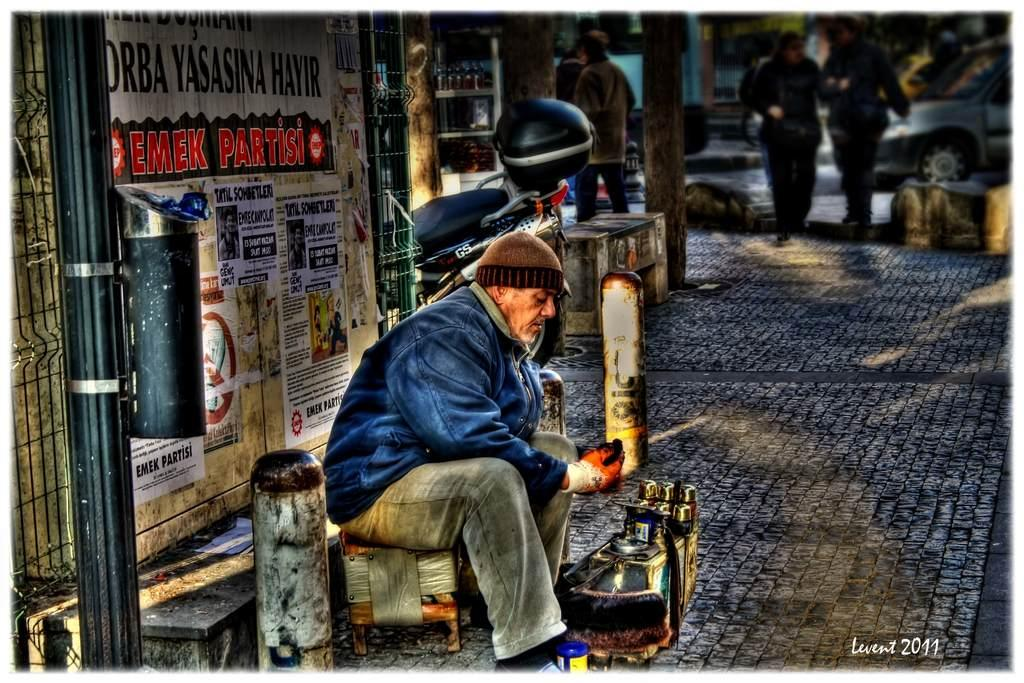What is the man in the image doing? The man is sitting on a chair and polishing shoes. Where is the scene taking place? The scene takes place on a footpath. What can be seen in the background of the image? People are walking on the footpath in the background. What is the income of the crowd gathered on the roof in the image? There is no crowd or roof present in the image; it features a man polishing shoes on a footpath. 